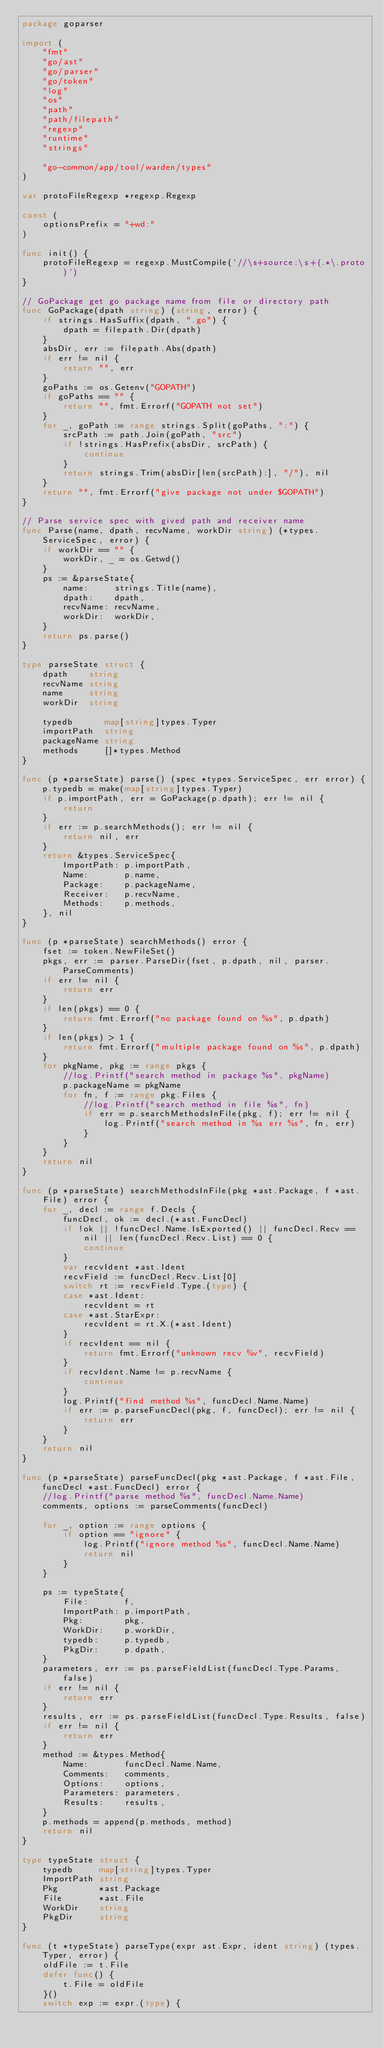Convert code to text. <code><loc_0><loc_0><loc_500><loc_500><_Go_>package goparser

import (
	"fmt"
	"go/ast"
	"go/parser"
	"go/token"
	"log"
	"os"
	"path"
	"path/filepath"
	"regexp"
	"runtime"
	"strings"

	"go-common/app/tool/warden/types"
)

var protoFileRegexp *regexp.Regexp

const (
	optionsPrefix = "+wd:"
)

func init() {
	protoFileRegexp = regexp.MustCompile(`//\s+source:\s+(.*\.proto)`)
}

// GoPackage get go package name from file or directory path
func GoPackage(dpath string) (string, error) {
	if strings.HasSuffix(dpath, ".go") {
		dpath = filepath.Dir(dpath)
	}
	absDir, err := filepath.Abs(dpath)
	if err != nil {
		return "", err
	}
	goPaths := os.Getenv("GOPATH")
	if goPaths == "" {
		return "", fmt.Errorf("GOPATH not set")
	}
	for _, goPath := range strings.Split(goPaths, ":") {
		srcPath := path.Join(goPath, "src")
		if !strings.HasPrefix(absDir, srcPath) {
			continue
		}
		return strings.Trim(absDir[len(srcPath):], "/"), nil
	}
	return "", fmt.Errorf("give package not under $GOPATH")
}

// Parse service spec with gived path and receiver name
func Parse(name, dpath, recvName, workDir string) (*types.ServiceSpec, error) {
	if workDir == "" {
		workDir, _ = os.Getwd()
	}
	ps := &parseState{
		name:     strings.Title(name),
		dpath:    dpath,
		recvName: recvName,
		workDir:  workDir,
	}
	return ps.parse()
}

type parseState struct {
	dpath    string
	recvName string
	name     string
	workDir  string

	typedb      map[string]types.Typer
	importPath  string
	packageName string
	methods     []*types.Method
}

func (p *parseState) parse() (spec *types.ServiceSpec, err error) {
	p.typedb = make(map[string]types.Typer)
	if p.importPath, err = GoPackage(p.dpath); err != nil {
		return
	}
	if err := p.searchMethods(); err != nil {
		return nil, err
	}
	return &types.ServiceSpec{
		ImportPath: p.importPath,
		Name:       p.name,
		Package:    p.packageName,
		Receiver:   p.recvName,
		Methods:    p.methods,
	}, nil
}

func (p *parseState) searchMethods() error {
	fset := token.NewFileSet()
	pkgs, err := parser.ParseDir(fset, p.dpath, nil, parser.ParseComments)
	if err != nil {
		return err
	}
	if len(pkgs) == 0 {
		return fmt.Errorf("no package found on %s", p.dpath)
	}
	if len(pkgs) > 1 {
		return fmt.Errorf("multiple package found on %s", p.dpath)
	}
	for pkgName, pkg := range pkgs {
		//log.Printf("search method in package %s", pkgName)
		p.packageName = pkgName
		for fn, f := range pkg.Files {
			//log.Printf("search method in file %s", fn)
			if err = p.searchMethodsInFile(pkg, f); err != nil {
				log.Printf("search method in %s err %s", fn, err)
			}
		}
	}
	return nil
}

func (p *parseState) searchMethodsInFile(pkg *ast.Package, f *ast.File) error {
	for _, decl := range f.Decls {
		funcDecl, ok := decl.(*ast.FuncDecl)
		if !ok || !funcDecl.Name.IsExported() || funcDecl.Recv == nil || len(funcDecl.Recv.List) == 0 {
			continue
		}
		var recvIdent *ast.Ident
		recvField := funcDecl.Recv.List[0]
		switch rt := recvField.Type.(type) {
		case *ast.Ident:
			recvIdent = rt
		case *ast.StarExpr:
			recvIdent = rt.X.(*ast.Ident)
		}
		if recvIdent == nil {
			return fmt.Errorf("unknown recv %v", recvField)
		}
		if recvIdent.Name != p.recvName {
			continue
		}
		log.Printf("find method %s", funcDecl.Name.Name)
		if err := p.parseFuncDecl(pkg, f, funcDecl); err != nil {
			return err
		}
	}
	return nil
}

func (p *parseState) parseFuncDecl(pkg *ast.Package, f *ast.File, funcDecl *ast.FuncDecl) error {
	//log.Printf("parse method %s", funcDecl.Name.Name)
	comments, options := parseComments(funcDecl)

	for _, option := range options {
		if option == "ignore" {
			log.Printf("ignore method %s", funcDecl.Name.Name)
			return nil
		}
	}

	ps := typeState{
		File:       f,
		ImportPath: p.importPath,
		Pkg:        pkg,
		WorkDir:    p.workDir,
		typedb:     p.typedb,
		PkgDir:     p.dpath,
	}
	parameters, err := ps.parseFieldList(funcDecl.Type.Params, false)
	if err != nil {
		return err
	}
	results, err := ps.parseFieldList(funcDecl.Type.Results, false)
	if err != nil {
		return err
	}
	method := &types.Method{
		Name:       funcDecl.Name.Name,
		Comments:   comments,
		Options:    options,
		Parameters: parameters,
		Results:    results,
	}
	p.methods = append(p.methods, method)
	return nil
}

type typeState struct {
	typedb     map[string]types.Typer
	ImportPath string
	Pkg        *ast.Package
	File       *ast.File
	WorkDir    string
	PkgDir     string
}

func (t *typeState) parseType(expr ast.Expr, ident string) (types.Typer, error) {
	oldFile := t.File
	defer func() {
		t.File = oldFile
	}()
	switch exp := expr.(type) {</code> 